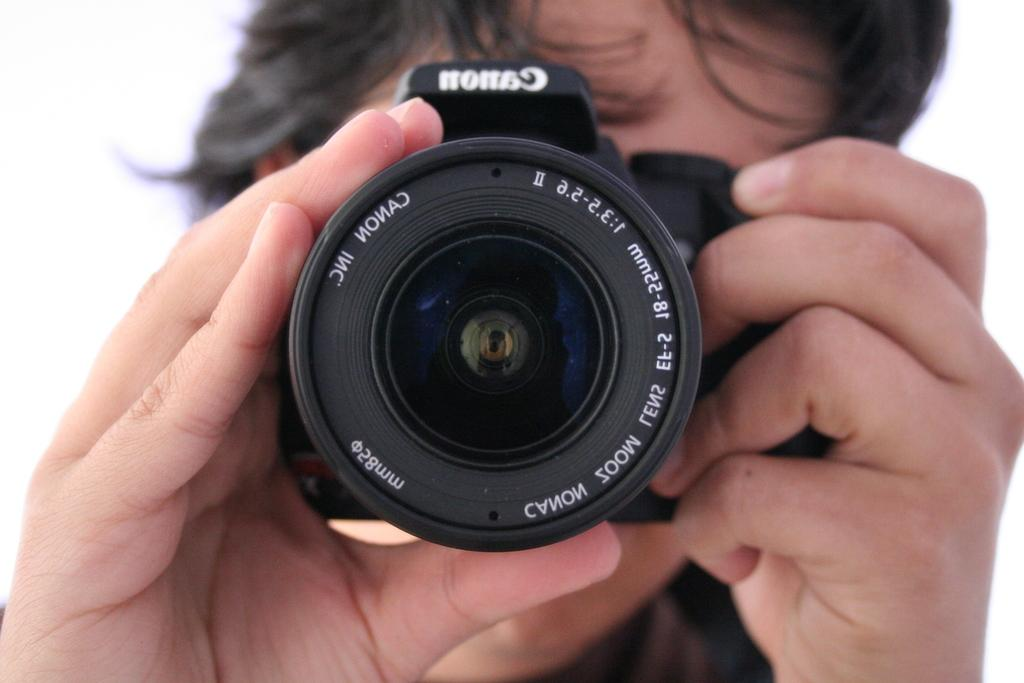<image>
Create a compact narrative representing the image presented. The front of a Canon SLR type camera being held and pointed away from someone's face. 